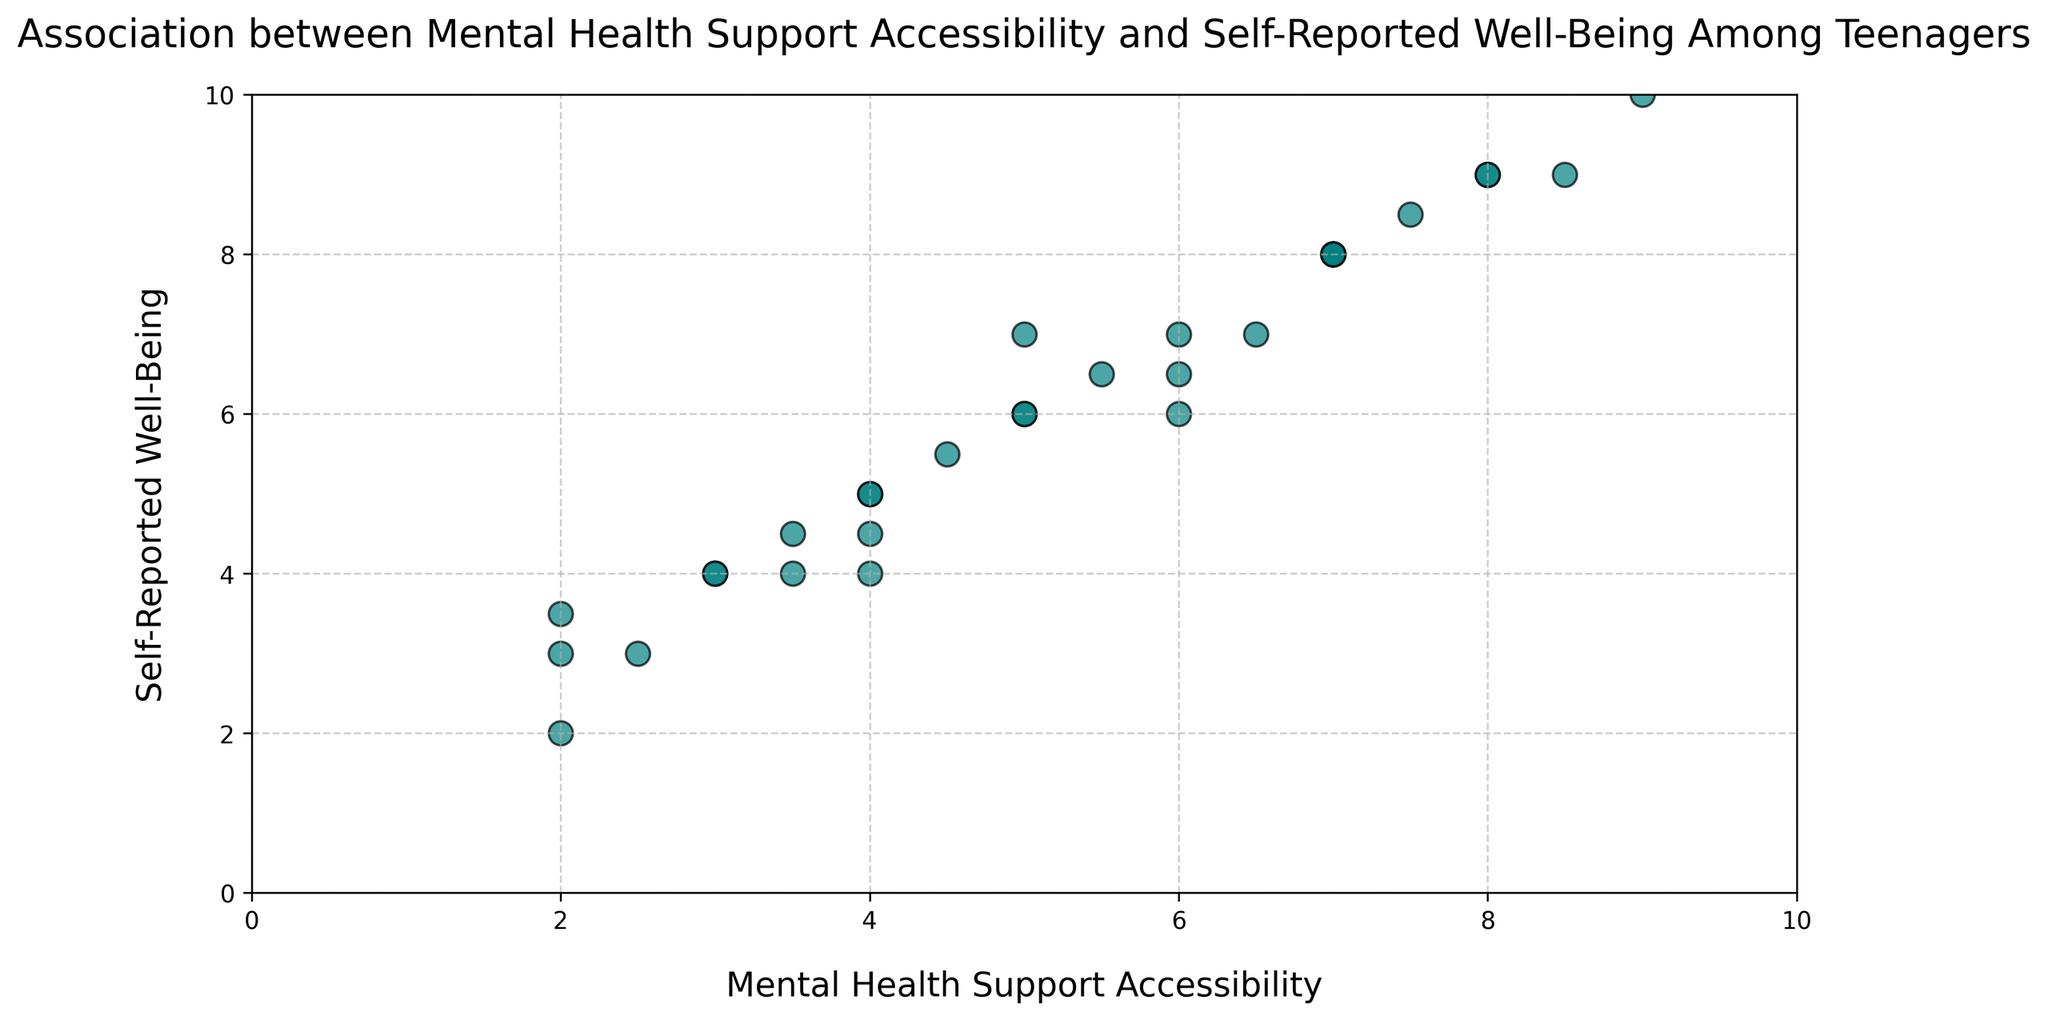What is the maximum value of self-reported well-being observed in the figure? To determine the maximum value of self-reported well-being, look at the y-axis and find the highest point reached by any of the scatter points. The highest point is at y = 10.
Answer: 10 What is the range of mental health support accessibility values in the figure? The range of mental health support accessibility values is the difference between the highest and lowest values on the x-axis. The highest value is 9 and the lowest is 2, so the range is 9 - 2.
Answer: 7 Is there a general trend between mental health support accessibility and self-reported well-being? You can observe if there is a general trend by looking at the direction of the scatter points. The points generally increase in self-reported well-being as mental health support accessibility increases, indicating a positive trend.
Answer: Positive trend What is the average self-reported well-being for teenagers with mental health support accessibility of 5 or higher? Identify the points where mental health support accessibility is 5 or higher and find their corresponding self-reported well-being values. The values are 7, 8, 7, 9, 6, 8, 9, 10, 8, 8. Find the average: (7 + 8 + 7 + 9 + 6 + 8 + 9 + 10 + 8 + 8) / 10.
Answer: 8 Do any points fall below a self-reported well-being of 5 with mental health support accessibility greater than 4? Identify the points where mental health support accessibility is greater than 4 and see if any have a self-reported well-being below 5. There are no such points; all points with accessibility greater than 4 have well-being of 5 or higher.
Answer: No How many data points indicate both high mental health support accessibility (≥ 6) and high self-reported well-being (≥ 7)? Count the number of points that satisfy both conditions: mental health support accessibility ≥ 6 and self-reported well-being ≥ 7. The points are (7, 8), (6, 7), (8, 9), (7, 8), (6.5, 7), (7.5, 8.5), (7, 8), (8, 9), (9, 10). There are 9 such points.
Answer: 9 What percentage of the points represent teenagers with self-reported well-being of 6 or above? Count the number of points with self-reported well-being of 6 or above and divide by the total number of points. There are 20 points with self-reported well-being 6 or above out of 30 points total. Calculate 20 / 30 * 100.
Answer: 66.67% What is the self-reported well-being value for the teenager with the lowest mental health support accessibility? Identify the point with the lowest mental health support accessibility (2) and note its self-reported well-being value. The point is (2, 3.5).
Answer: 3.5 Compare the number of teenagers with mental health support accessibility below 5 to those with accessibility 5 or higher. Count the number of points on either side of the mental health support accessibility value of 5. There are 10 points below 5 and 20 points at 5 or higher.
Answer: 10 below, 20 at or above 